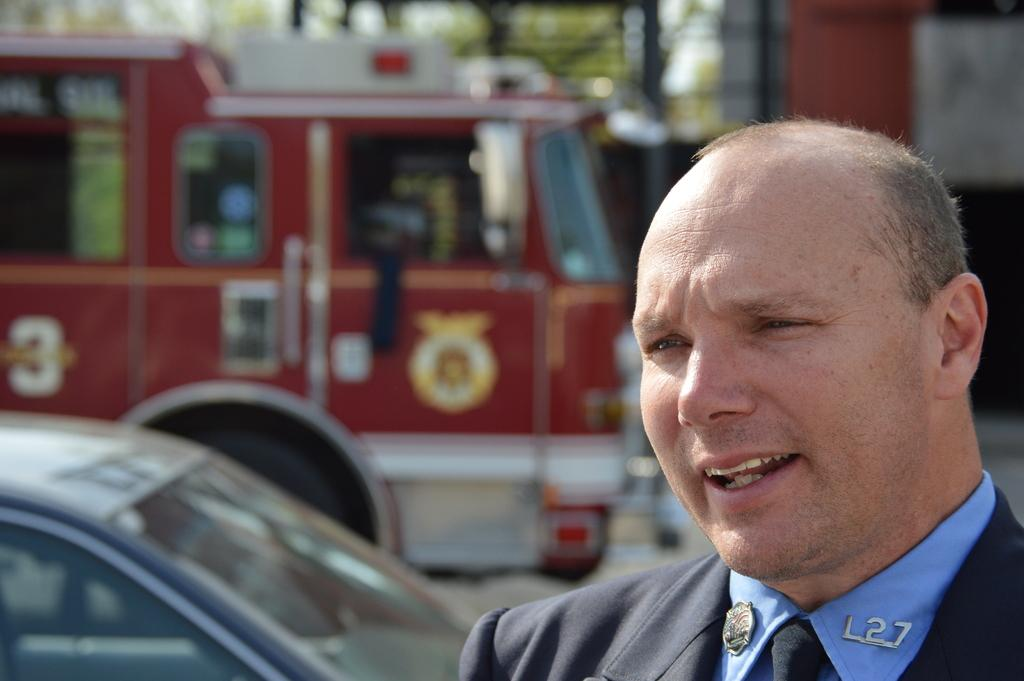Who is present in the image? There is a person in the image. What is the person wearing? The person is wearing a blue shirt. What can be seen on the road in the image? There are two vehicles on the road. Can you describe the background of the image? The background of the image is blurry. What type of care is the person providing for the tomatoes in the image? There are no tomatoes present in the image, so it is not possible to answer that question. 